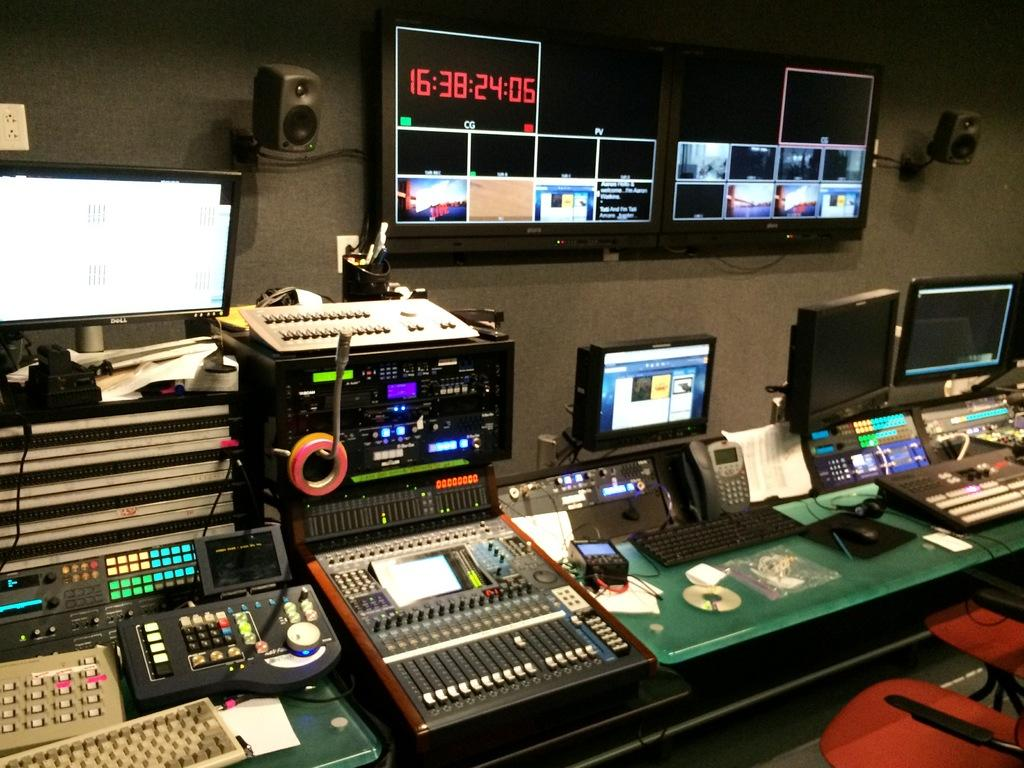<image>
Render a clear and concise summary of the photo. A series of television recording equipment and a clock on the large screen that reads 16:38:24:05. 